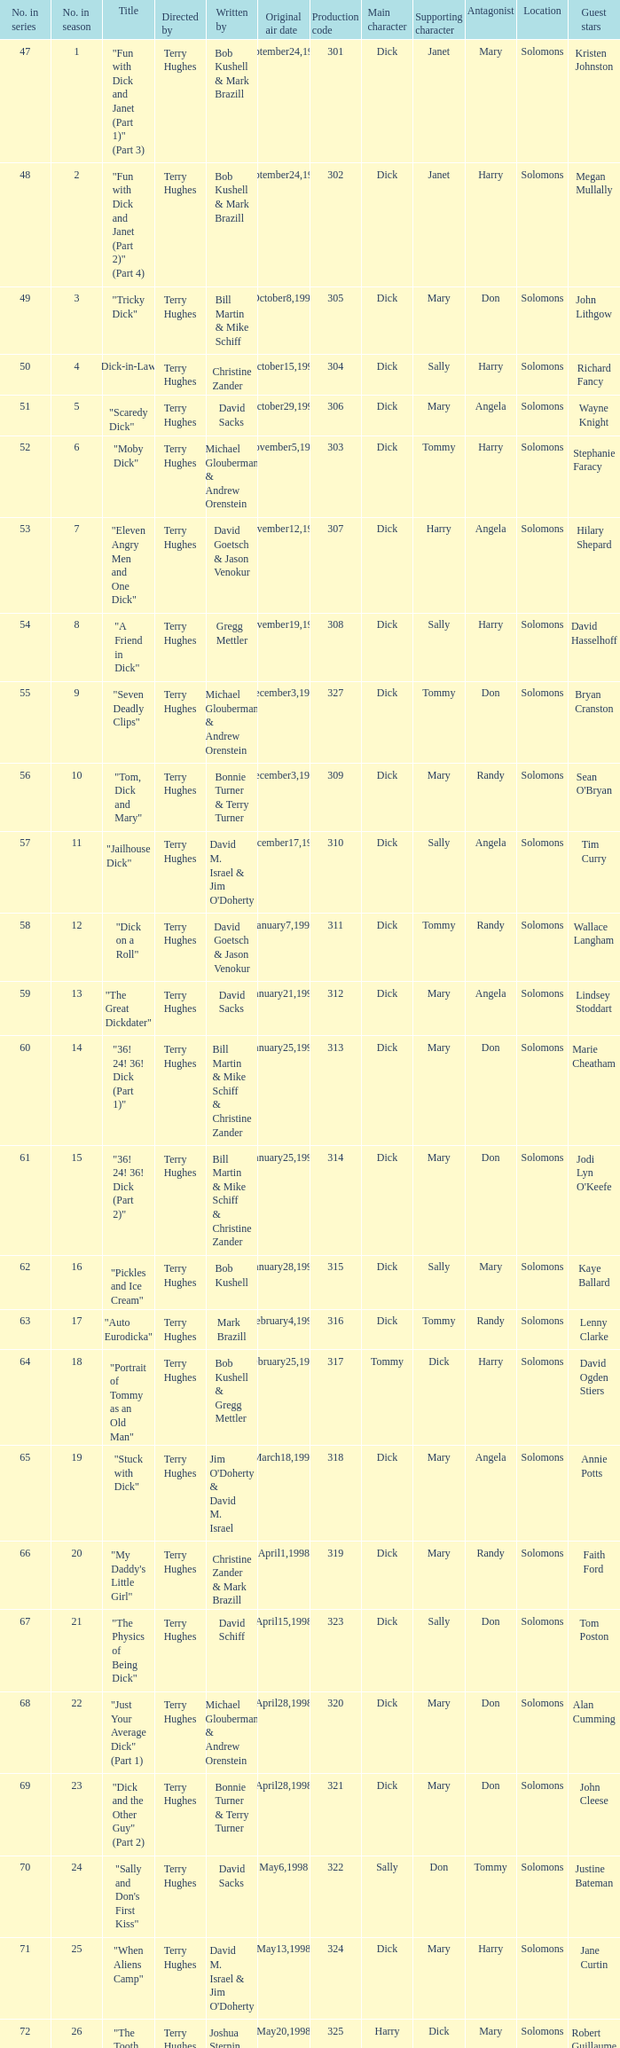What is the original air date of the episode with production code is 319? April1,1998. 